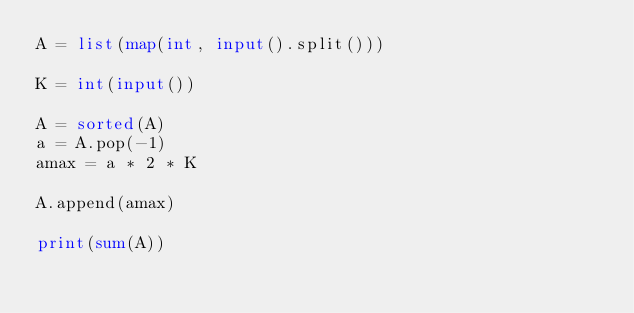<code> <loc_0><loc_0><loc_500><loc_500><_Python_>A = list(map(int, input().split()))

K = int(input())

A = sorted(A)
a = A.pop(-1)
amax = a * 2 * K

A.append(amax)

print(sum(A))</code> 